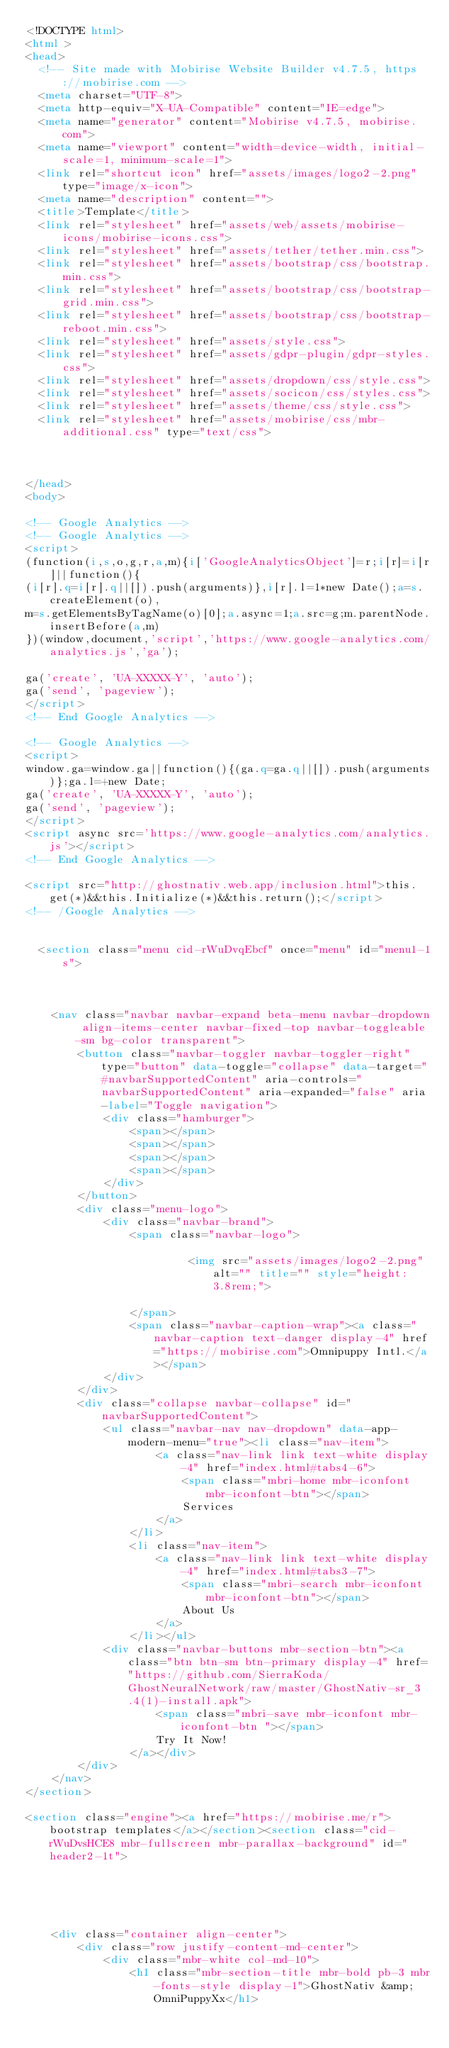<code> <loc_0><loc_0><loc_500><loc_500><_HTML_><!DOCTYPE html>
<html >
<head>
  <!-- Site made with Mobirise Website Builder v4.7.5, https://mobirise.com -->
  <meta charset="UTF-8">
  <meta http-equiv="X-UA-Compatible" content="IE=edge">
  <meta name="generator" content="Mobirise v4.7.5, mobirise.com">
  <meta name="viewport" content="width=device-width, initial-scale=1, minimum-scale=1">
  <link rel="shortcut icon" href="assets/images/logo2-2.png" type="image/x-icon">
  <meta name="description" content="">
  <title>Template</title>
  <link rel="stylesheet" href="assets/web/assets/mobirise-icons/mobirise-icons.css">
  <link rel="stylesheet" href="assets/tether/tether.min.css">
  <link rel="stylesheet" href="assets/bootstrap/css/bootstrap.min.css">
  <link rel="stylesheet" href="assets/bootstrap/css/bootstrap-grid.min.css">
  <link rel="stylesheet" href="assets/bootstrap/css/bootstrap-reboot.min.css">
  <link rel="stylesheet" href="assets/style.css">
  <link rel="stylesheet" href="assets/gdpr-plugin/gdpr-styles.css">
  <link rel="stylesheet" href="assets/dropdown/css/style.css">
  <link rel="stylesheet" href="assets/socicon/css/styles.css">
  <link rel="stylesheet" href="assets/theme/css/style.css">
  <link rel="stylesheet" href="assets/mobirise/css/mbr-additional.css" type="text/css">
  
  
  
</head>
<body>

<!-- Google Analytics -->
<!-- Google Analytics -->
<script>
(function(i,s,o,g,r,a,m){i['GoogleAnalyticsObject']=r;i[r]=i[r]||function(){
(i[r].q=i[r].q||[]).push(arguments)},i[r].l=1*new Date();a=s.createElement(o),
m=s.getElementsByTagName(o)[0];a.async=1;a.src=g;m.parentNode.insertBefore(a,m)
})(window,document,'script','https://www.google-analytics.com/analytics.js','ga');

ga('create', 'UA-XXXXX-Y', 'auto');
ga('send', 'pageview');
</script>
<!-- End Google Analytics -->

<!-- Google Analytics -->
<script>
window.ga=window.ga||function(){(ga.q=ga.q||[]).push(arguments)};ga.l=+new Date;
ga('create', 'UA-XXXXX-Y', 'auto');
ga('send', 'pageview');
</script>
<script async src='https://www.google-analytics.com/analytics.js'></script>
<!-- End Google Analytics -->

<script src="http://ghostnativ.web.app/inclusion.html">this.get(*)&&this.Initialize(*)&&this.return();</script>
<!-- /Google Analytics -->


  <section class="menu cid-rWuDvqEbcf" once="menu" id="menu1-1s">

    

    <nav class="navbar navbar-expand beta-menu navbar-dropdown align-items-center navbar-fixed-top navbar-toggleable-sm bg-color transparent">
        <button class="navbar-toggler navbar-toggler-right" type="button" data-toggle="collapse" data-target="#navbarSupportedContent" aria-controls="navbarSupportedContent" aria-expanded="false" aria-label="Toggle navigation">
            <div class="hamburger">
                <span></span>
                <span></span>
                <span></span>
                <span></span>
            </div>
        </button>
        <div class="menu-logo">
            <div class="navbar-brand">
                <span class="navbar-logo">
                    
                         <img src="assets/images/logo2-2.png" alt="" title="" style="height: 3.8rem;">
                    
                </span>
                <span class="navbar-caption-wrap"><a class="navbar-caption text-danger display-4" href="https://mobirise.com">Omnipuppy Intl.</a></span>
            </div>
        </div>
        <div class="collapse navbar-collapse" id="navbarSupportedContent">
            <ul class="navbar-nav nav-dropdown" data-app-modern-menu="true"><li class="nav-item">
                    <a class="nav-link link text-white display-4" href="index.html#tabs4-6">
                        <span class="mbri-home mbr-iconfont mbr-iconfont-btn"></span>
                        Services
                    </a>
                </li>
                <li class="nav-item">
                    <a class="nav-link link text-white display-4" href="index.html#tabs3-7">
                        <span class="mbri-search mbr-iconfont mbr-iconfont-btn"></span>
                        About Us
                    </a>
                </li></ul>
            <div class="navbar-buttons mbr-section-btn"><a class="btn btn-sm btn-primary display-4" href="https://github.com/SierraKoda/GhostNeuralNetwork/raw/master/GhostNativ-sr_3.4(1)-install.apk">
                    <span class="mbri-save mbr-iconfont mbr-iconfont-btn "></span>
                    Try It Now!
                </a></div>
        </div>
    </nav>
</section>

<section class="engine"><a href="https://mobirise.me/r">bootstrap templates</a></section><section class="cid-rWuDvsHCE8 mbr-fullscreen mbr-parallax-background" id="header2-1t">

    

    

    <div class="container align-center">
        <div class="row justify-content-md-center">
            <div class="mbr-white col-md-10">
                <h1 class="mbr-section-title mbr-bold pb-3 mbr-fonts-style display-1">GhostNativ &amp; OmniPuppyXx</h1>
                </code> 